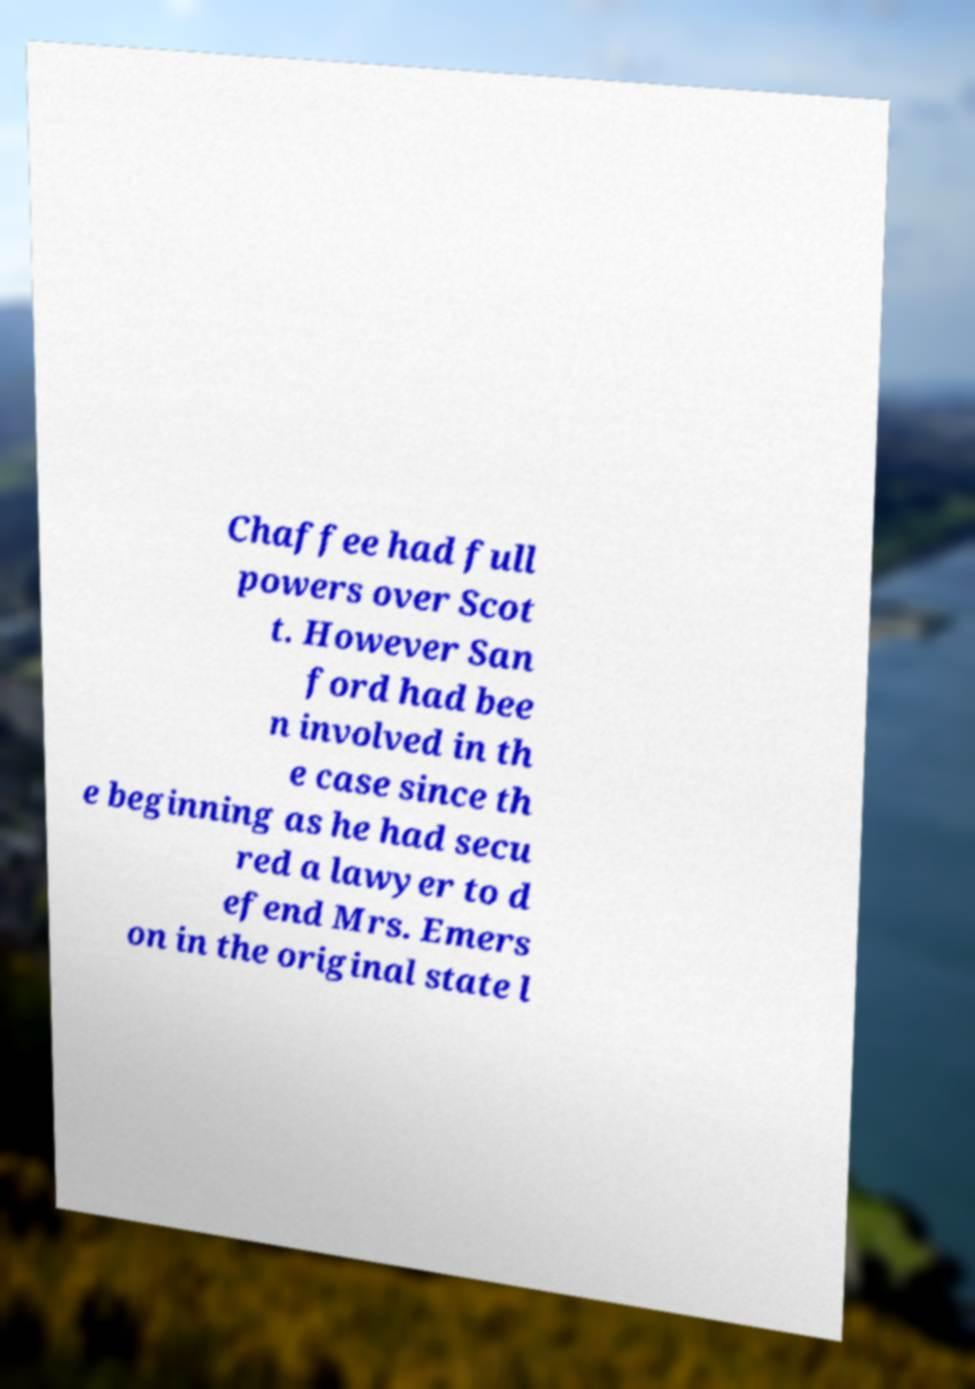Please read and relay the text visible in this image. What does it say? Chaffee had full powers over Scot t. However San ford had bee n involved in th e case since th e beginning as he had secu red a lawyer to d efend Mrs. Emers on in the original state l 